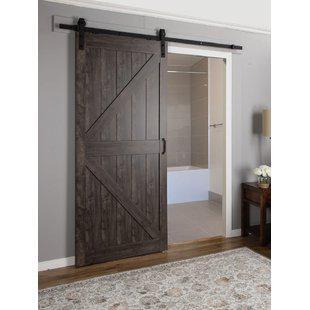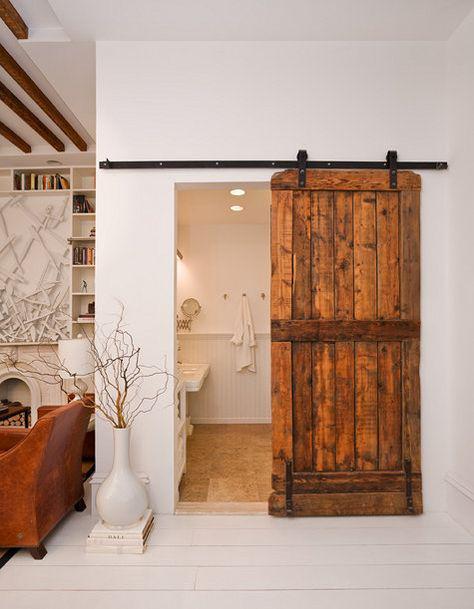The first image is the image on the left, the second image is the image on the right. For the images displayed, is the sentence "The left and right image contains the same number of hanging doors made of solid wood." factually correct? Answer yes or no. Yes. The first image is the image on the left, the second image is the image on the right. Evaluate the accuracy of this statement regarding the images: "The right image shows a sliding door to the left of the dooorway.". Is it true? Answer yes or no. No. 